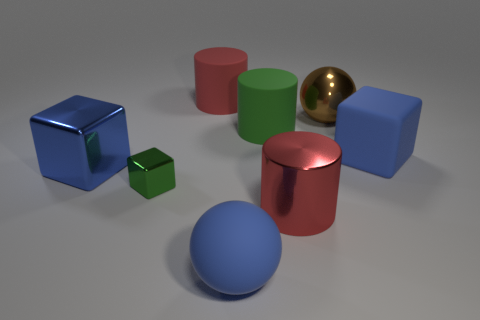Add 1 large red metallic things. How many objects exist? 9 Subtract all cubes. How many objects are left? 5 Add 4 big red things. How many big red things are left? 6 Add 2 big rubber things. How many big rubber things exist? 6 Subtract 1 red cylinders. How many objects are left? 7 Subtract all matte cylinders. Subtract all spheres. How many objects are left? 4 